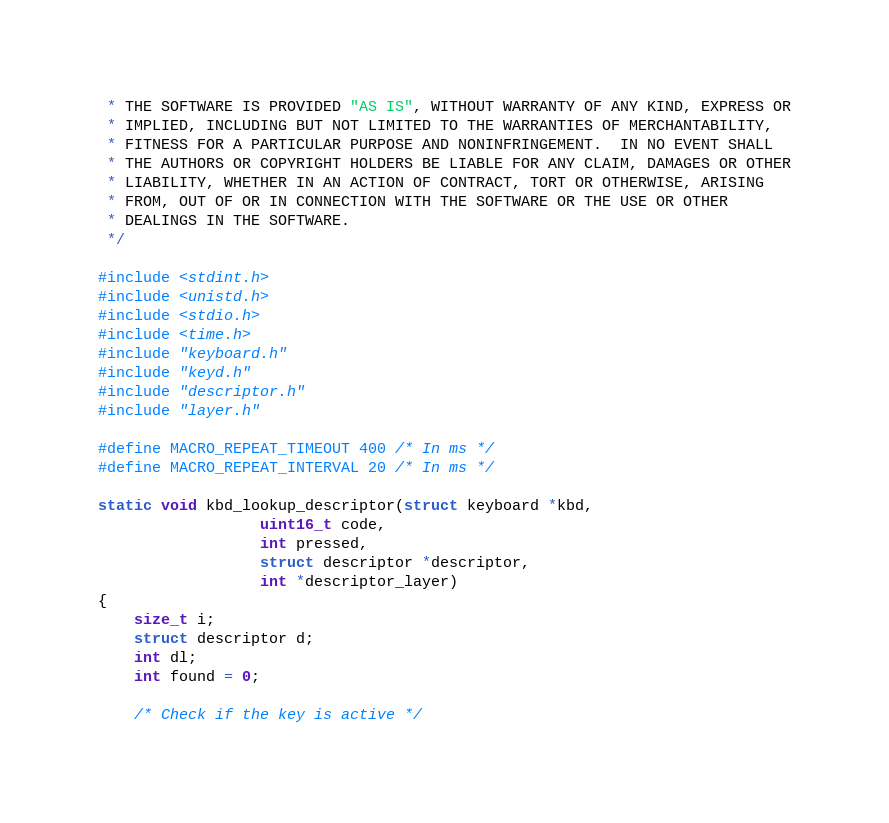<code> <loc_0><loc_0><loc_500><loc_500><_C_> * THE SOFTWARE IS PROVIDED "AS IS", WITHOUT WARRANTY OF ANY KIND, EXPRESS OR
 * IMPLIED, INCLUDING BUT NOT LIMITED TO THE WARRANTIES OF MERCHANTABILITY,
 * FITNESS FOR A PARTICULAR PURPOSE AND NONINFRINGEMENT.  IN NO EVENT SHALL
 * THE AUTHORS OR COPYRIGHT HOLDERS BE LIABLE FOR ANY CLAIM, DAMAGES OR OTHER
 * LIABILITY, WHETHER IN AN ACTION OF CONTRACT, TORT OR OTHERWISE, ARISING
 * FROM, OUT OF OR IN CONNECTION WITH THE SOFTWARE OR THE USE OR OTHER
 * DEALINGS IN THE SOFTWARE.
 */

#include <stdint.h>
#include <unistd.h>
#include <stdio.h>
#include <time.h>
#include "keyboard.h"
#include "keyd.h"
#include "descriptor.h"
#include "layer.h"

#define MACRO_REPEAT_TIMEOUT 400 /* In ms */
#define MACRO_REPEAT_INTERVAL 20 /* In ms */

static void kbd_lookup_descriptor(struct keyboard *kbd,
				  uint16_t code,
				  int pressed,
				  struct descriptor *descriptor,
				  int *descriptor_layer)
{
	size_t i;
	struct descriptor d;
	int dl;
	int found = 0;

	/* Check if the key is active */</code> 